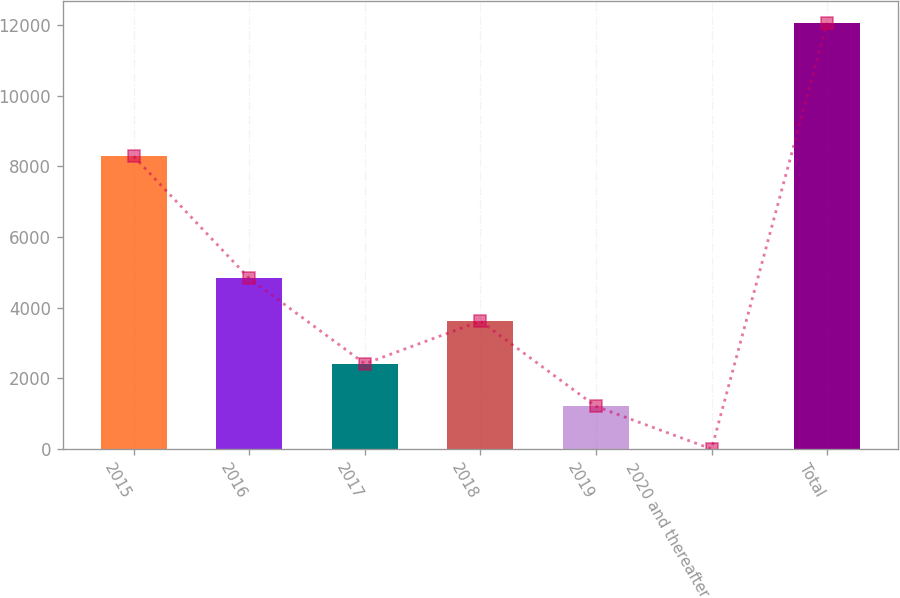Convert chart to OTSL. <chart><loc_0><loc_0><loc_500><loc_500><bar_chart><fcel>2015<fcel>2016<fcel>2017<fcel>2018<fcel>2019<fcel>2020 and thereafter<fcel>Total<nl><fcel>8278<fcel>4827.4<fcel>2417.2<fcel>3622.3<fcel>1212.1<fcel>7<fcel>12058<nl></chart> 